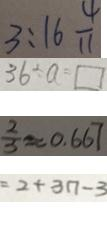<formula> <loc_0><loc_0><loc_500><loc_500>3 : 1 6 \frac { 4 } { 1 1 } 
 3 6 \div a = \square 
 \frac { 2 } { 3 } \approx 0 . 6 6 7 
 = 2 + 3 n - 3</formula> 